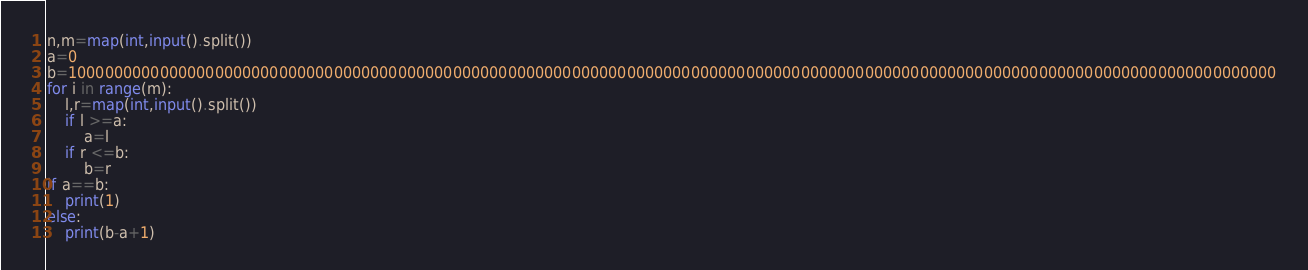<code> <loc_0><loc_0><loc_500><loc_500><_Python_>n,m=map(int,input().split())
a=0
b=100000000000000000000000000000000000000000000000000000000000000000000000000000000000000000000000000000000000000000000000000000000000
for i in range(m):
    l,r=map(int,input().split())
    if l >=a:
        a=l
    if r <=b:
        b=r
if a==b:
    print(1)
else:
    print(b-a+1)</code> 